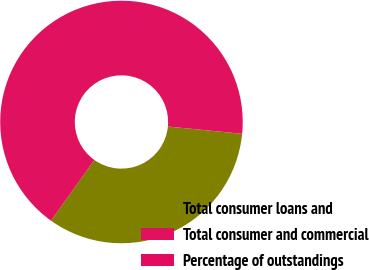Convert chart. <chart><loc_0><loc_0><loc_500><loc_500><pie_chart><fcel>Total consumer loans and<fcel>Total consumer and commercial<fcel>Percentage of outstandings<nl><fcel>33.3%<fcel>66.69%<fcel>0.01%<nl></chart> 